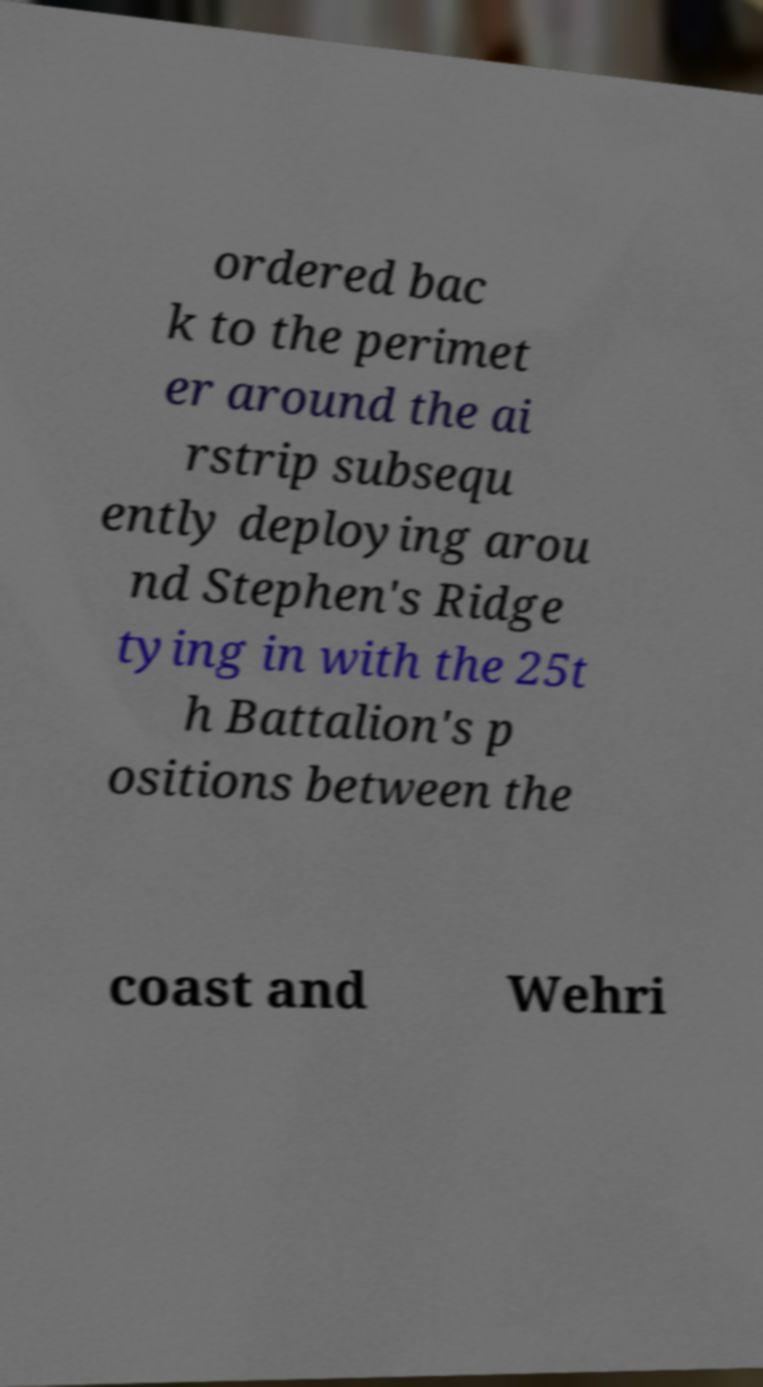Could you extract and type out the text from this image? ordered bac k to the perimet er around the ai rstrip subsequ ently deploying arou nd Stephen's Ridge tying in with the 25t h Battalion's p ositions between the coast and Wehri 